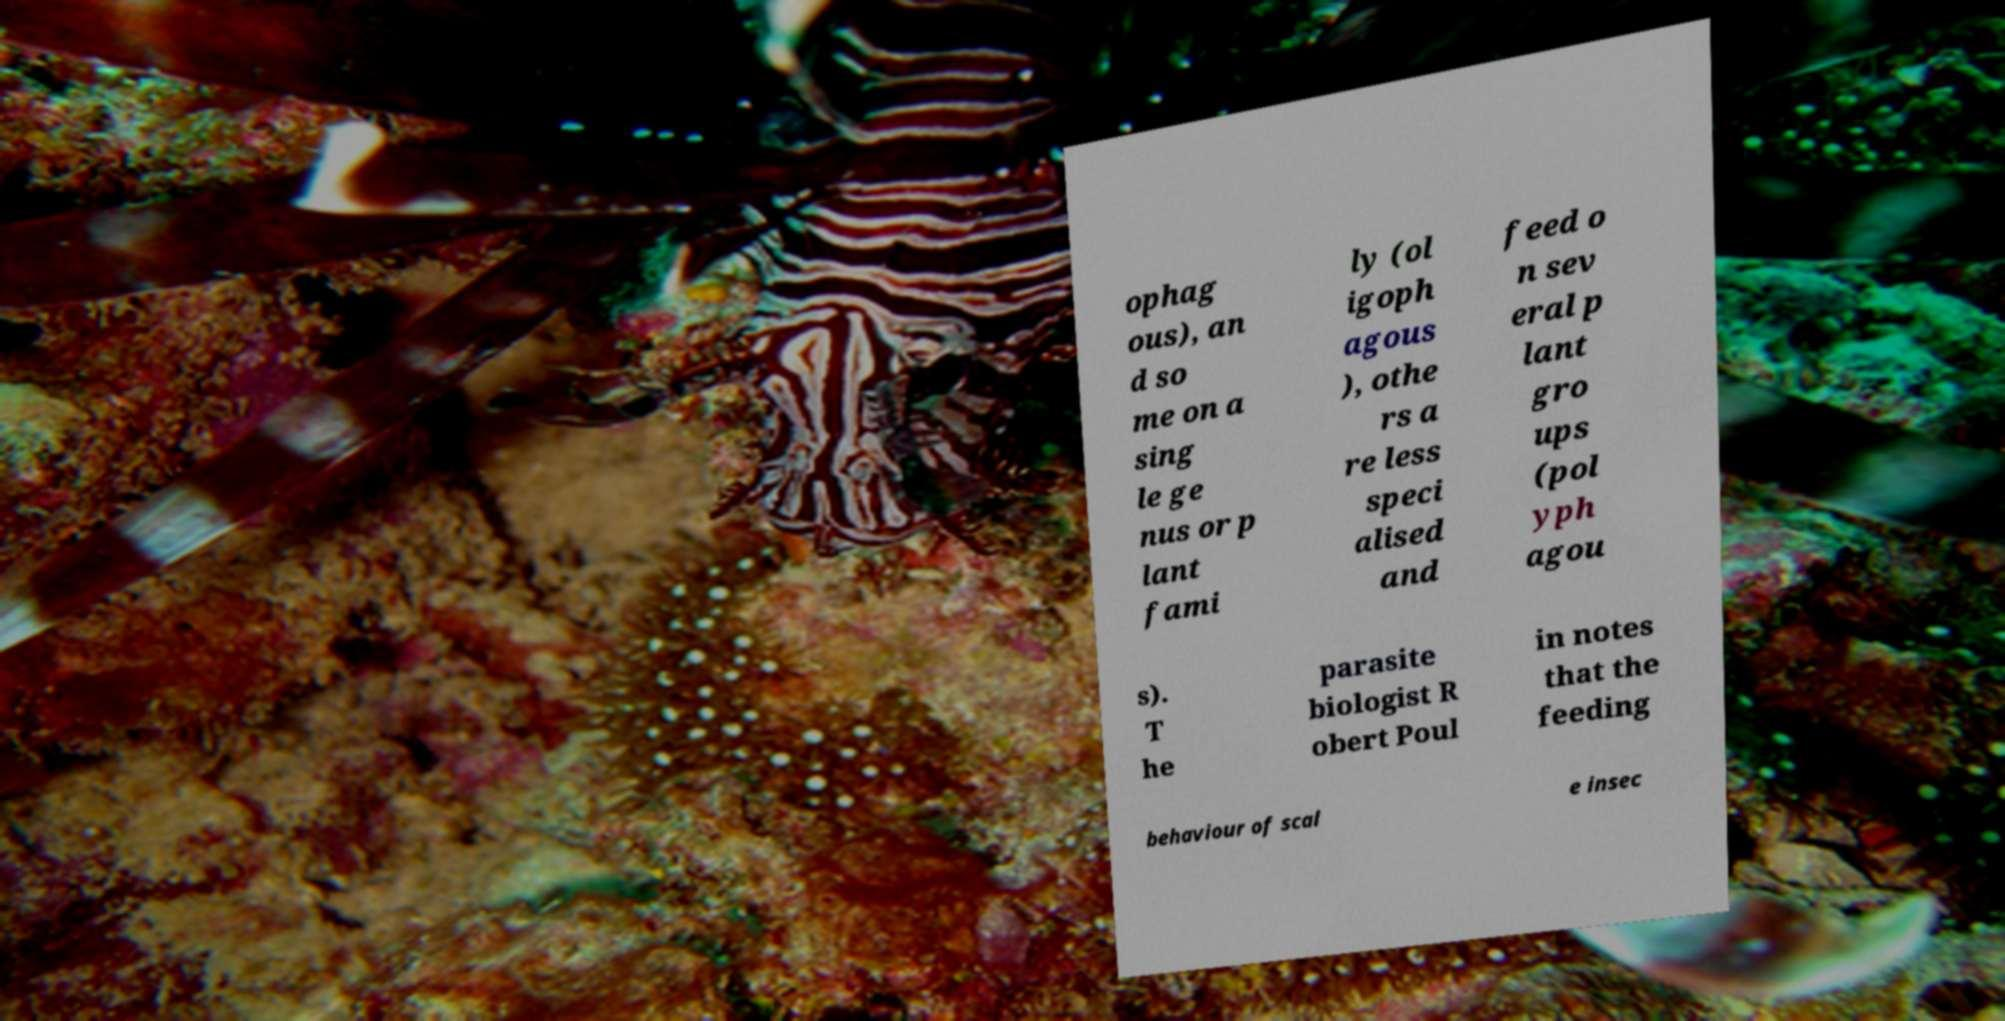Can you accurately transcribe the text from the provided image for me? ophag ous), an d so me on a sing le ge nus or p lant fami ly (ol igoph agous ), othe rs a re less speci alised and feed o n sev eral p lant gro ups (pol yph agou s). T he parasite biologist R obert Poul in notes that the feeding behaviour of scal e insec 